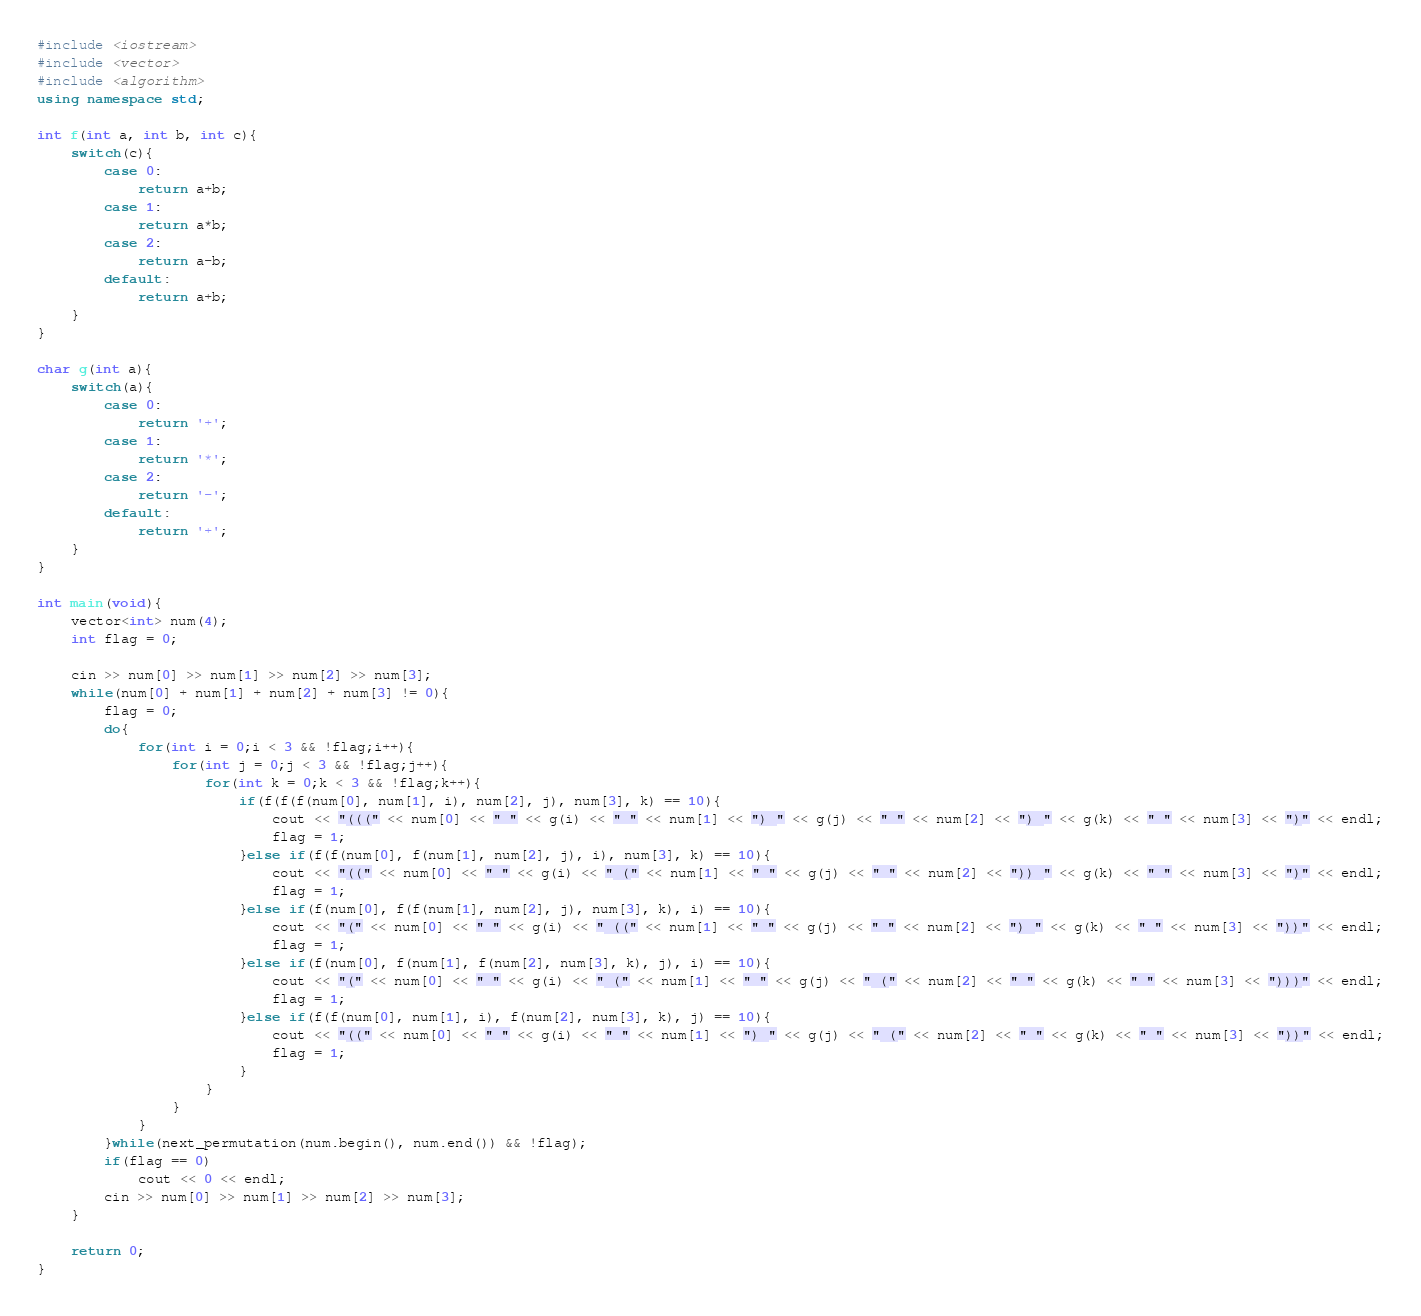Convert code to text. <code><loc_0><loc_0><loc_500><loc_500><_C++_>#include <iostream>
#include <vector>
#include <algorithm>
using namespace std;

int f(int a, int b, int c){
    switch(c){
        case 0:
            return a+b;
        case 1:
            return a*b;
        case 2:
            return a-b;
        default:
            return a+b;
    }
}

char g(int a){
    switch(a){
        case 0:
            return '+';
        case 1:
            return '*';
        case 2:
            return '-';
        default:
            return '+';
    }
}

int main(void){
    vector<int> num(4);
    int flag = 0;

    cin >> num[0] >> num[1] >> num[2] >> num[3];
    while(num[0] + num[1] + num[2] + num[3] != 0){
        flag = 0;
        do{
            for(int i = 0;i < 3 && !flag;i++){
                for(int j = 0;j < 3 && !flag;j++){
                    for(int k = 0;k < 3 && !flag;k++){
                        if(f(f(f(num[0], num[1], i), num[2], j), num[3], k) == 10){
                            cout << "(((" << num[0] << " " << g(i) << " " << num[1] << ") " << g(j) << " " << num[2] << ") " << g(k) << " " << num[3] << ")" << endl;
                            flag = 1;
                        }else if(f(f(num[0], f(num[1], num[2], j), i), num[3], k) == 10){
                            cout << "((" << num[0] << " " << g(i) << " (" << num[1] << " " << g(j) << " " << num[2] << ")) " << g(k) << " " << num[3] << ")" << endl;
                            flag = 1;
                        }else if(f(num[0], f(f(num[1], num[2], j), num[3], k), i) == 10){
                            cout << "(" << num[0] << " " << g(i) << " ((" << num[1] << " " << g(j) << " " << num[2] << ") " << g(k) << " " << num[3] << "))" << endl;
                            flag = 1;
                        }else if(f(num[0], f(num[1], f(num[2], num[3], k), j), i) == 10){
                            cout << "(" << num[0] << " " << g(i) << " (" << num[1] << " " << g(j) << " (" << num[2] << " " << g(k) << " " << num[3] << ")))" << endl;
                            flag = 1;
                        }else if(f(f(num[0], num[1], i), f(num[2], num[3], k), j) == 10){
                            cout << "((" << num[0] << " " << g(i) << " " << num[1] << ") " << g(j) << " (" << num[2] << " " << g(k) << " " << num[3] << "))" << endl;
                            flag = 1;
                        }
                    }
                }
            }
        }while(next_permutation(num.begin(), num.end()) && !flag);
        if(flag == 0)
            cout << 0 << endl;
        cin >> num[0] >> num[1] >> num[2] >> num[3];
    }

    return 0;
}</code> 